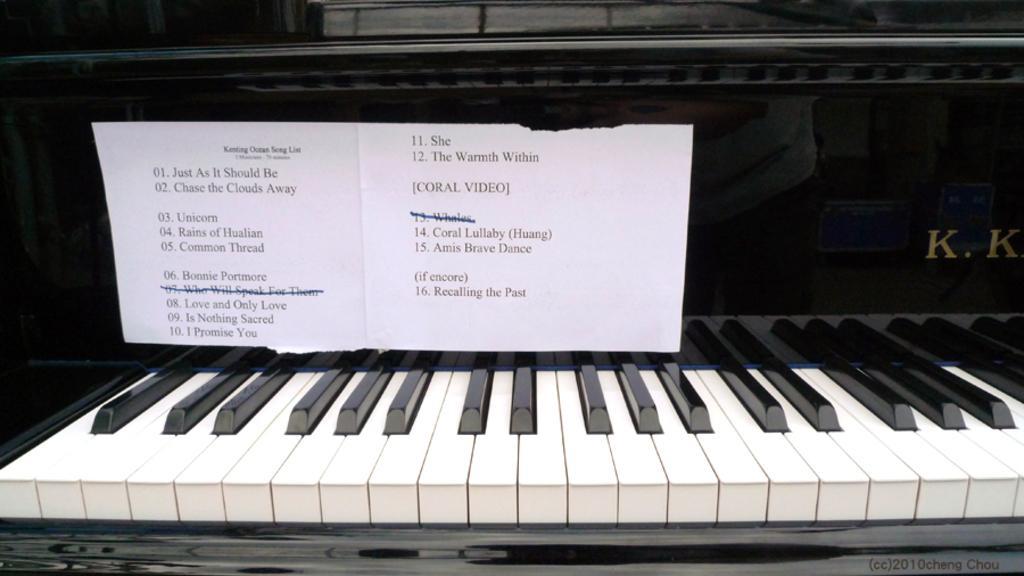In one or two sentences, can you explain what this image depicts? In this image I can see a piano on which a white color paper is sticked. 